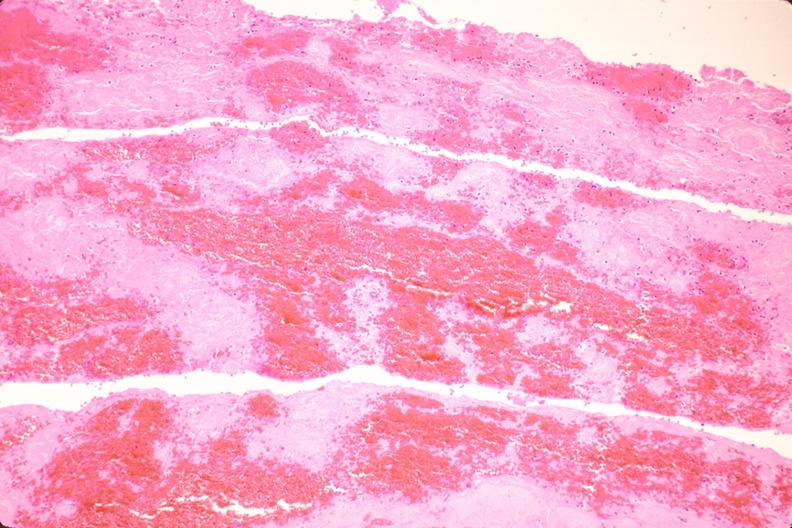s papillary intraductal adenocarcinoma present?
Answer the question using a single word or phrase. No 